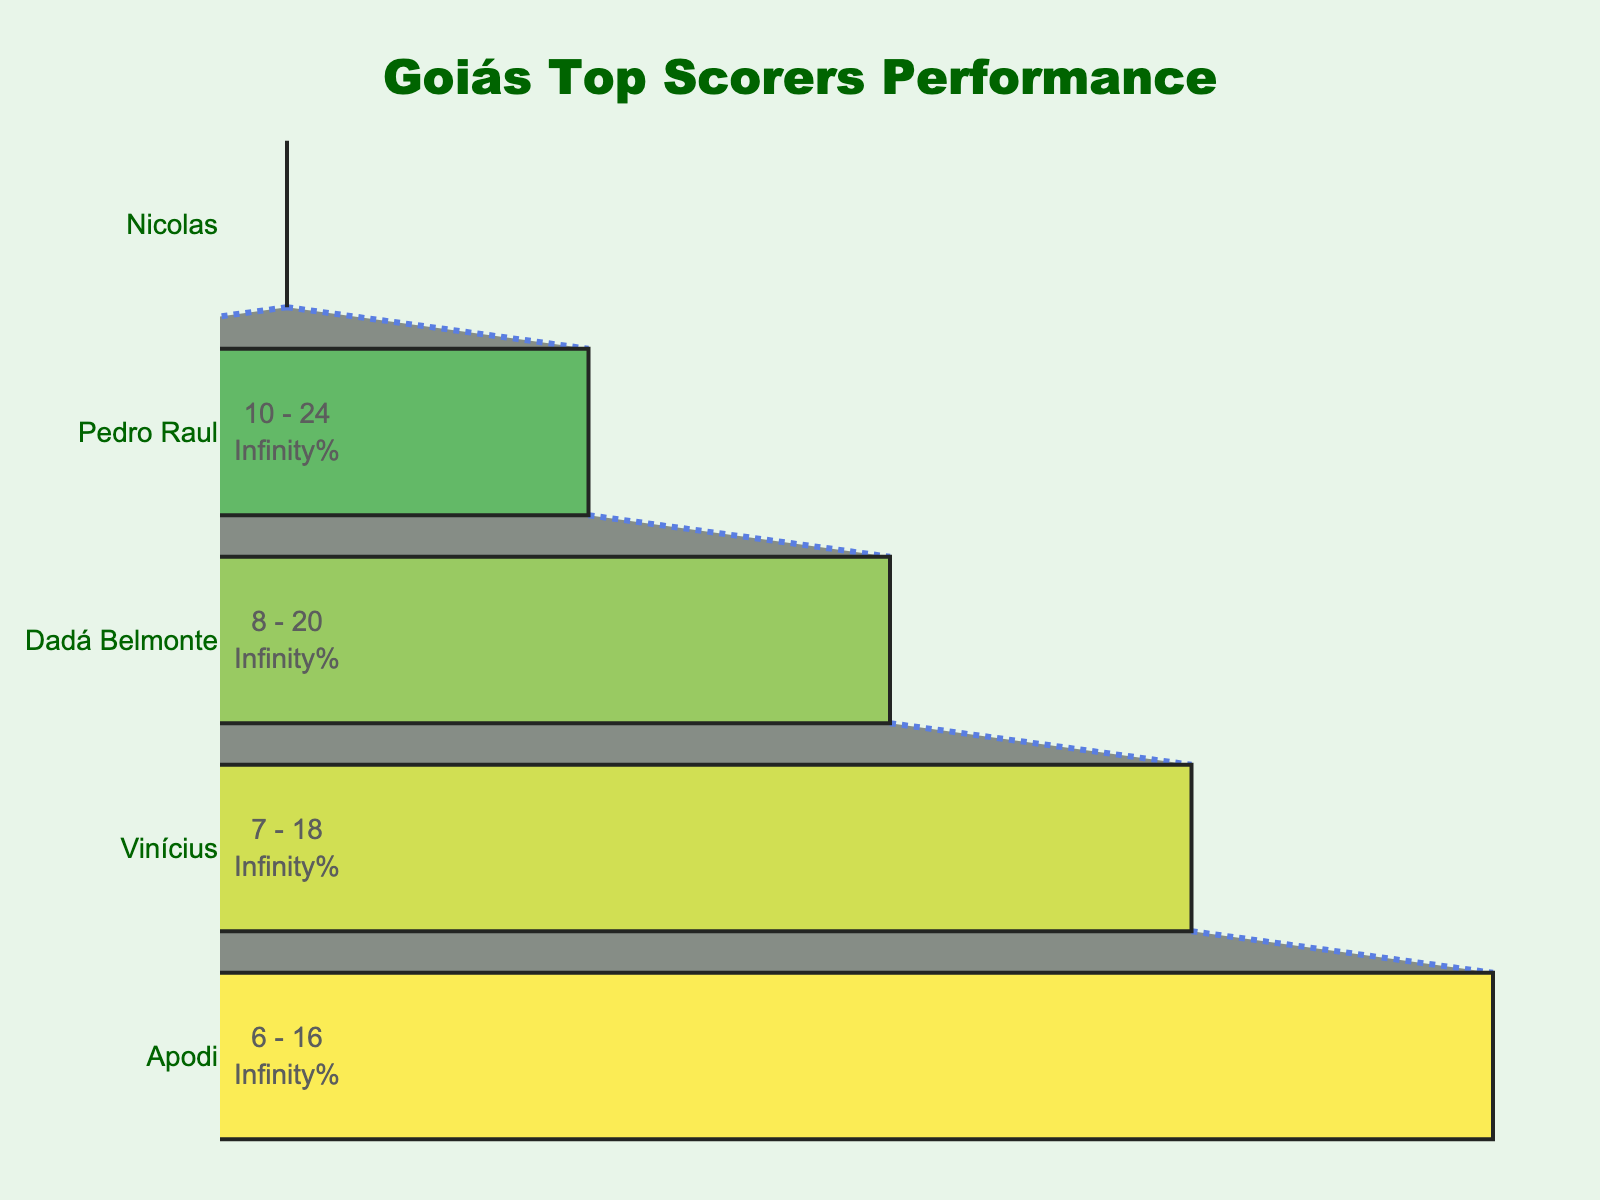What does the title of the Funnel Chart say? The title of the Funnel Chart is usually placed at the top of the chart. In this case, we can see the title displayed clearly at the top center.
Answer: Goiás Top Scorers Performance What is the total number of goals scored by the top 5 goal scorers? To find the total number of goals, sum the individual goals scored by each player: 12 (Nicolas) + 10 (Pedro Raul) + 8 (Dadá Belmonte) + 7 (Vinícius) + 6 (Apodi).
Answer: 43 Who created the most chances among the players? By comparing the "Chances Created" section for all players, we see the number of chances created by each player. The player with the highest number is the one who created the most chances.
Answer: Apodi Which player has the highest number of shots on target? By examining the "Shots on Target" section, we identify the player with the largest value in this category.
Answer: Nicolas What is the difference in goals scored between Nicolas and Vinícius? Subtract the number of goals scored by Vinícius from the number of goals scored by Nicolas: 12 - 7.
Answer: 5 How many total shots were made by the top 3 goal scorers combined? To find this, we sum the "Total Shots" for Nicolas, Pedro Raul, and Dadá Belmonte: 45 + 38 + 32.
Answer: 115 Compare the chances created by Dadá Belmonte and Vinícius. Who created more and by how much? We examine the values for "Chances Created" for both players and subtract the smaller value from the larger one: 22 (Vinícius) - 18 (Dadá Belmonte).
Answer: Vinícius created 4 more chances What percentage of Nicolas's total shots were on target? To calculate this percentage, divide Nicolas’s shots on target by his total shots and multiply by 100: (28 / 45) * 100.
Answer: 62.2% Between Pedro Raul and Apodi, who had a better shots on target to total shots ratio? Calculate the ratio of shots on target to total shots for both Pedro Raul and Apodi and compare the two values: Pedro Raul (24/38) and Apodi (16/28).
Answer: Pedro Raul What color represents the data for Apodi in this chart? The colors in the funnel chart follow a predefined sequence. By observing the chart and knowing the order of players listed, we identify which color corresponds to Apodi.
Answer: Yellow 